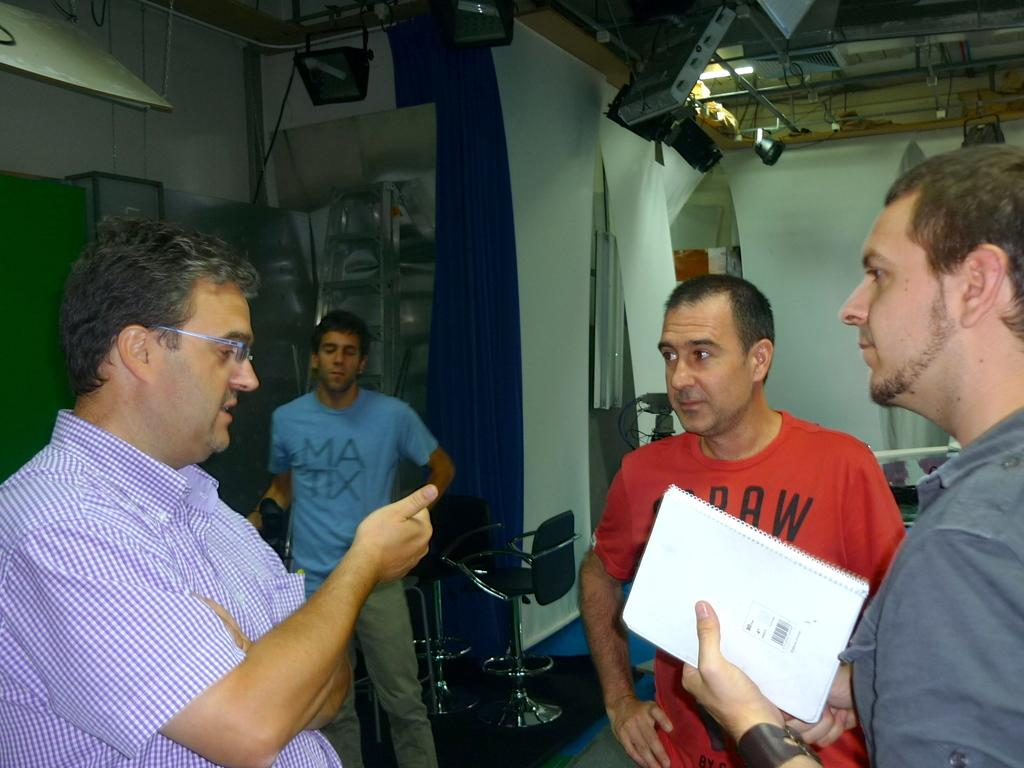How many men are present in the image? There are four men in the image. What is one of the men holding? One man is holding a book. What type of furniture can be seen in the image? There are chairs in the image. What type of window treatment is present in the image? There are curtains in the image. What type of structure is visible in the image? There are walls in the image. What can be seen in the background of the image? There are objects visible in the background of the image. What type of bucket is being used to connect the walls in the image? There is no bucket present in the image, nor is there any indication of a connection between the walls. 